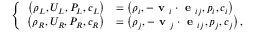<formula> <loc_0><loc_0><loc_500><loc_500>\left \{ \begin{array} { r l } { \left ( \rho _ { L } , U _ { L } , P _ { L } , c _ { L } \right ) } & { = \left ( \rho _ { i } , - v _ { i } \cdot e _ { i j } , p _ { i } , c _ { i } \right ) } \\ { \left ( \rho _ { R } , U _ { R } , P _ { R } , c _ { R } \right ) } & { = \left ( \rho _ { j } , - v _ { j } \cdot e _ { i j } , p _ { j } , c _ { j } \right ) , } \end{array}</formula> 